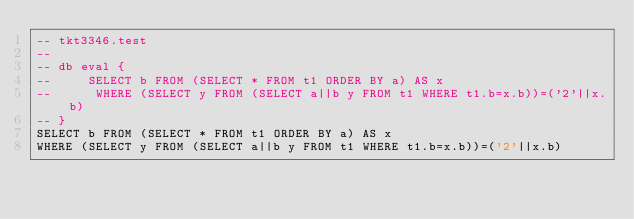Convert code to text. <code><loc_0><loc_0><loc_500><loc_500><_SQL_>-- tkt3346.test
-- 
-- db eval {
--     SELECT b FROM (SELECT * FROM t1 ORDER BY a) AS x
--      WHERE (SELECT y FROM (SELECT a||b y FROM t1 WHERE t1.b=x.b))=('2'||x.b)
-- }
SELECT b FROM (SELECT * FROM t1 ORDER BY a) AS x
WHERE (SELECT y FROM (SELECT a||b y FROM t1 WHERE t1.b=x.b))=('2'||x.b)</code> 